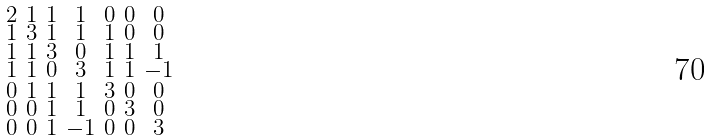Convert formula to latex. <formula><loc_0><loc_0><loc_500><loc_500>\begin{smallmatrix} 2 & 1 & 1 & 1 & 0 & 0 & 0 \\ 1 & 3 & 1 & 1 & 1 & 0 & 0 \\ 1 & 1 & 3 & 0 & 1 & 1 & 1 \\ 1 & 1 & 0 & 3 & 1 & 1 & - 1 \\ 0 & 1 & 1 & 1 & 3 & 0 & 0 \\ 0 & 0 & 1 & 1 & 0 & 3 & 0 \\ 0 & 0 & 1 & - 1 & 0 & 0 & 3 \end{smallmatrix}</formula> 